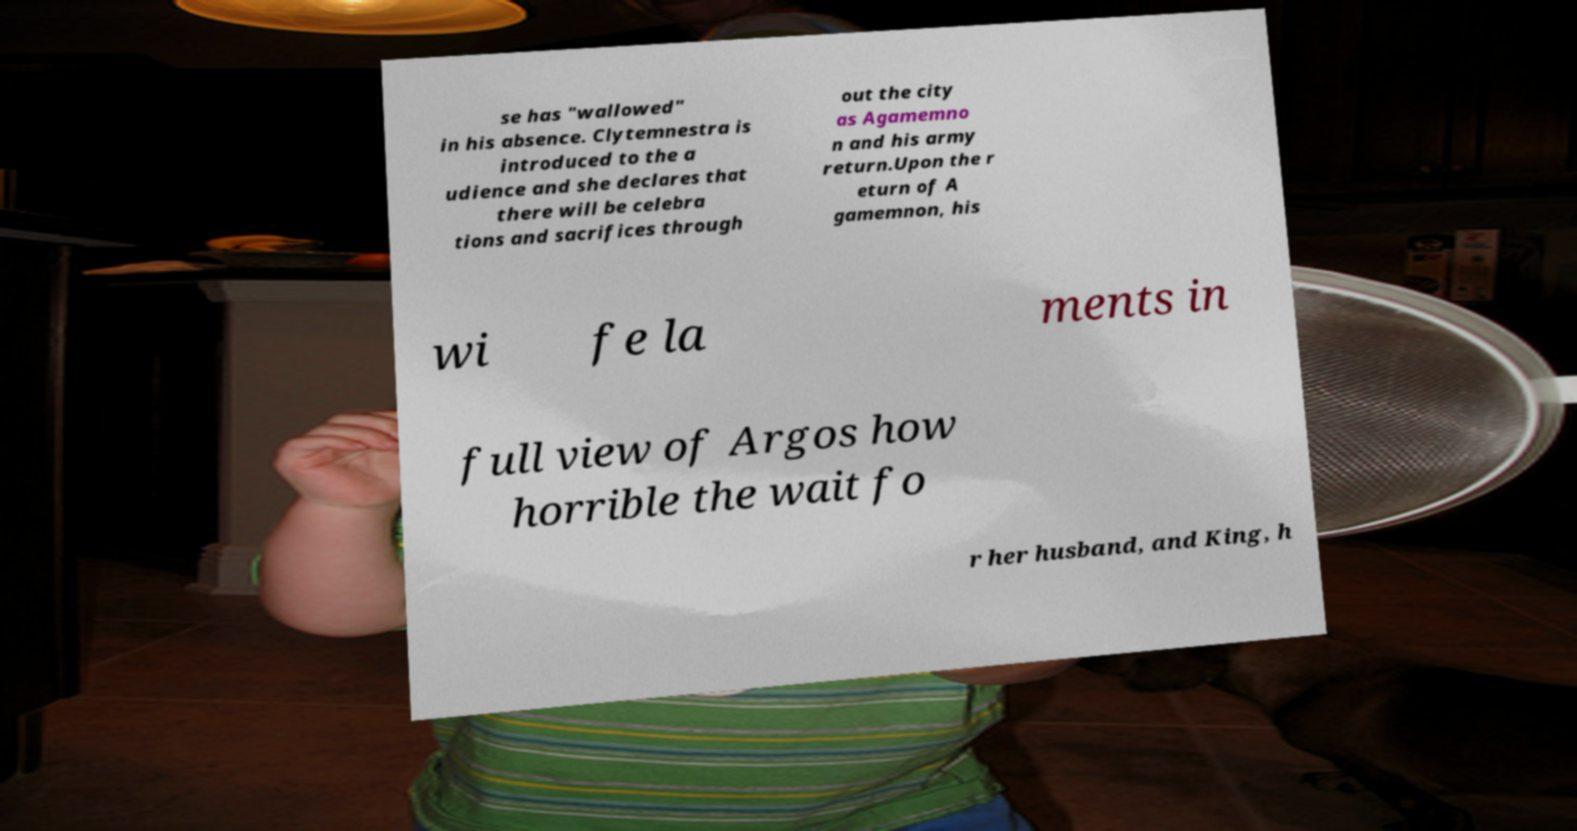Please identify and transcribe the text found in this image. se has "wallowed" in his absence. Clytemnestra is introduced to the a udience and she declares that there will be celebra tions and sacrifices through out the city as Agamemno n and his army return.Upon the r eturn of A gamemnon, his wi fe la ments in full view of Argos how horrible the wait fo r her husband, and King, h 